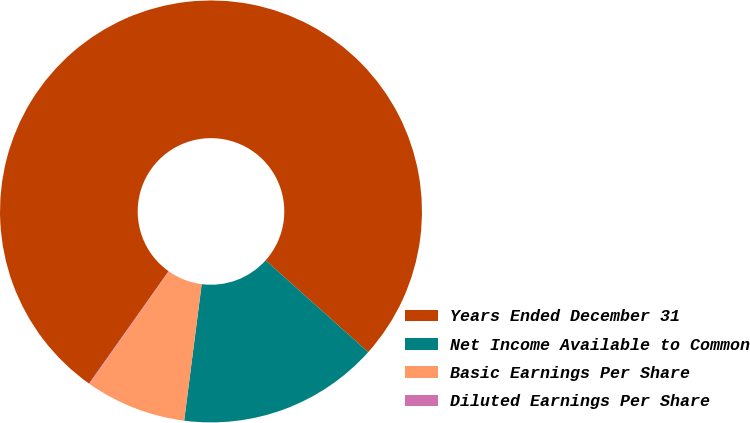<chart> <loc_0><loc_0><loc_500><loc_500><pie_chart><fcel>Years Ended December 31<fcel>Net Income Available to Common<fcel>Basic Earnings Per Share<fcel>Diluted Earnings Per Share<nl><fcel>76.81%<fcel>15.41%<fcel>7.73%<fcel>0.05%<nl></chart> 